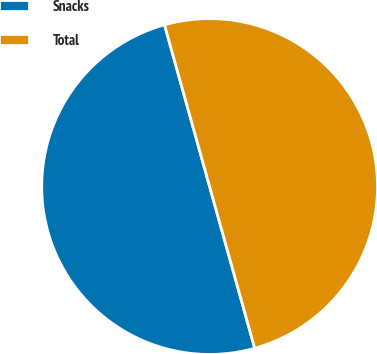Convert chart to OTSL. <chart><loc_0><loc_0><loc_500><loc_500><pie_chart><fcel>Snacks<fcel>Total<nl><fcel>50.0%<fcel>50.0%<nl></chart> 